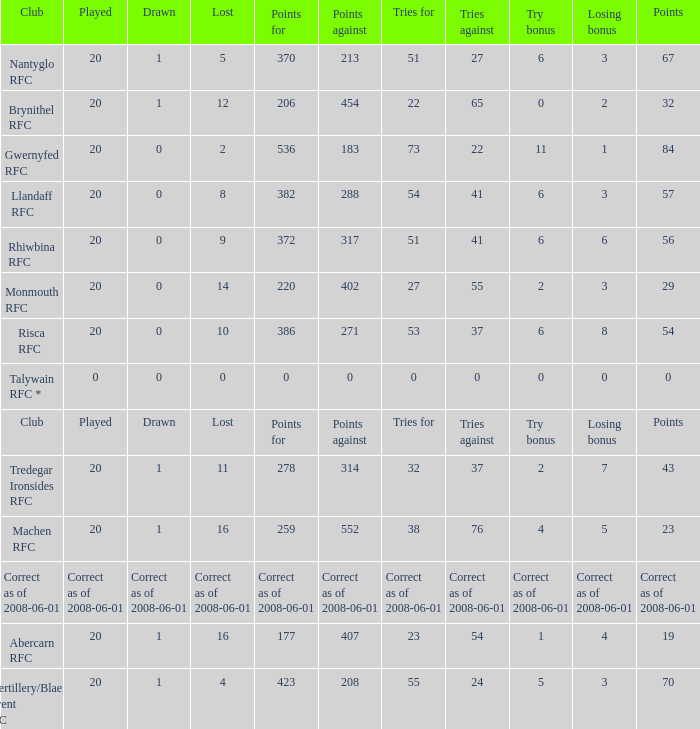If the points were 0, what were the tries for? 0.0. 